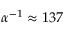Convert formula to latex. <formula><loc_0><loc_0><loc_500><loc_500>\alpha ^ { - 1 } \approx 1 3 7</formula> 